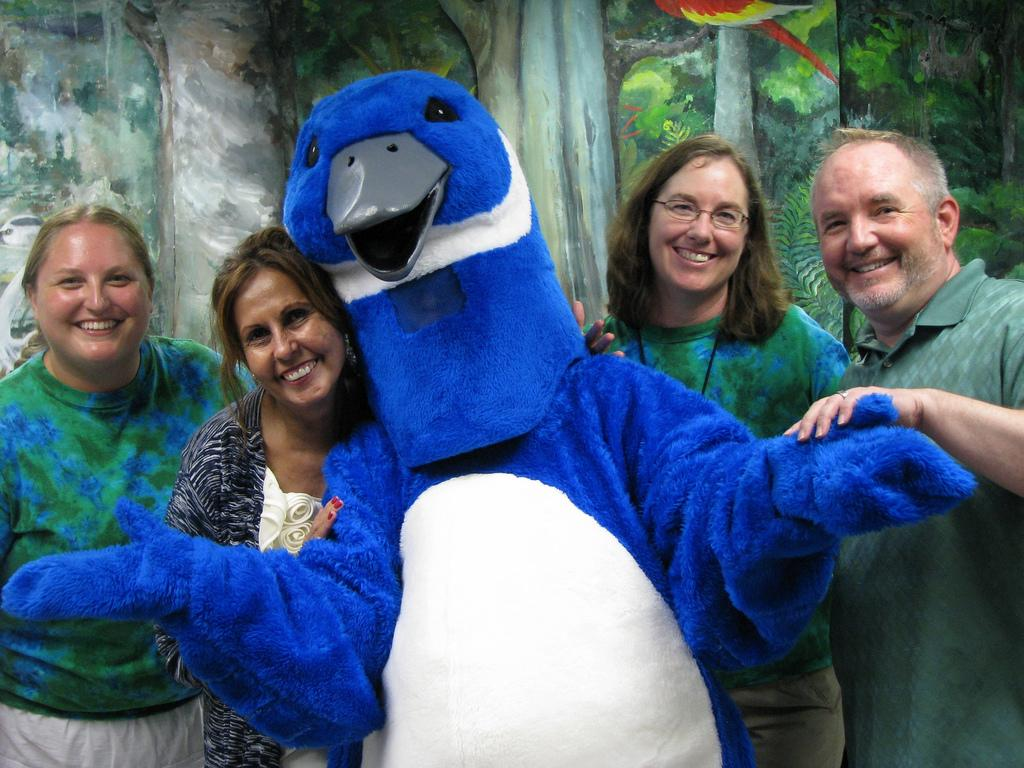What is the person in the image wearing? There is a person wearing a costume in the image. How are the people in the image feeling? There are people with smiles in the image, suggesting they are happy or enjoying themselves. What can be seen in the background of the image? There is a painting in the background of the image. How many hands are visible in the image? There is no mention of hands in the provided facts, so it is impossible to determine how many hands are visible in the image. 